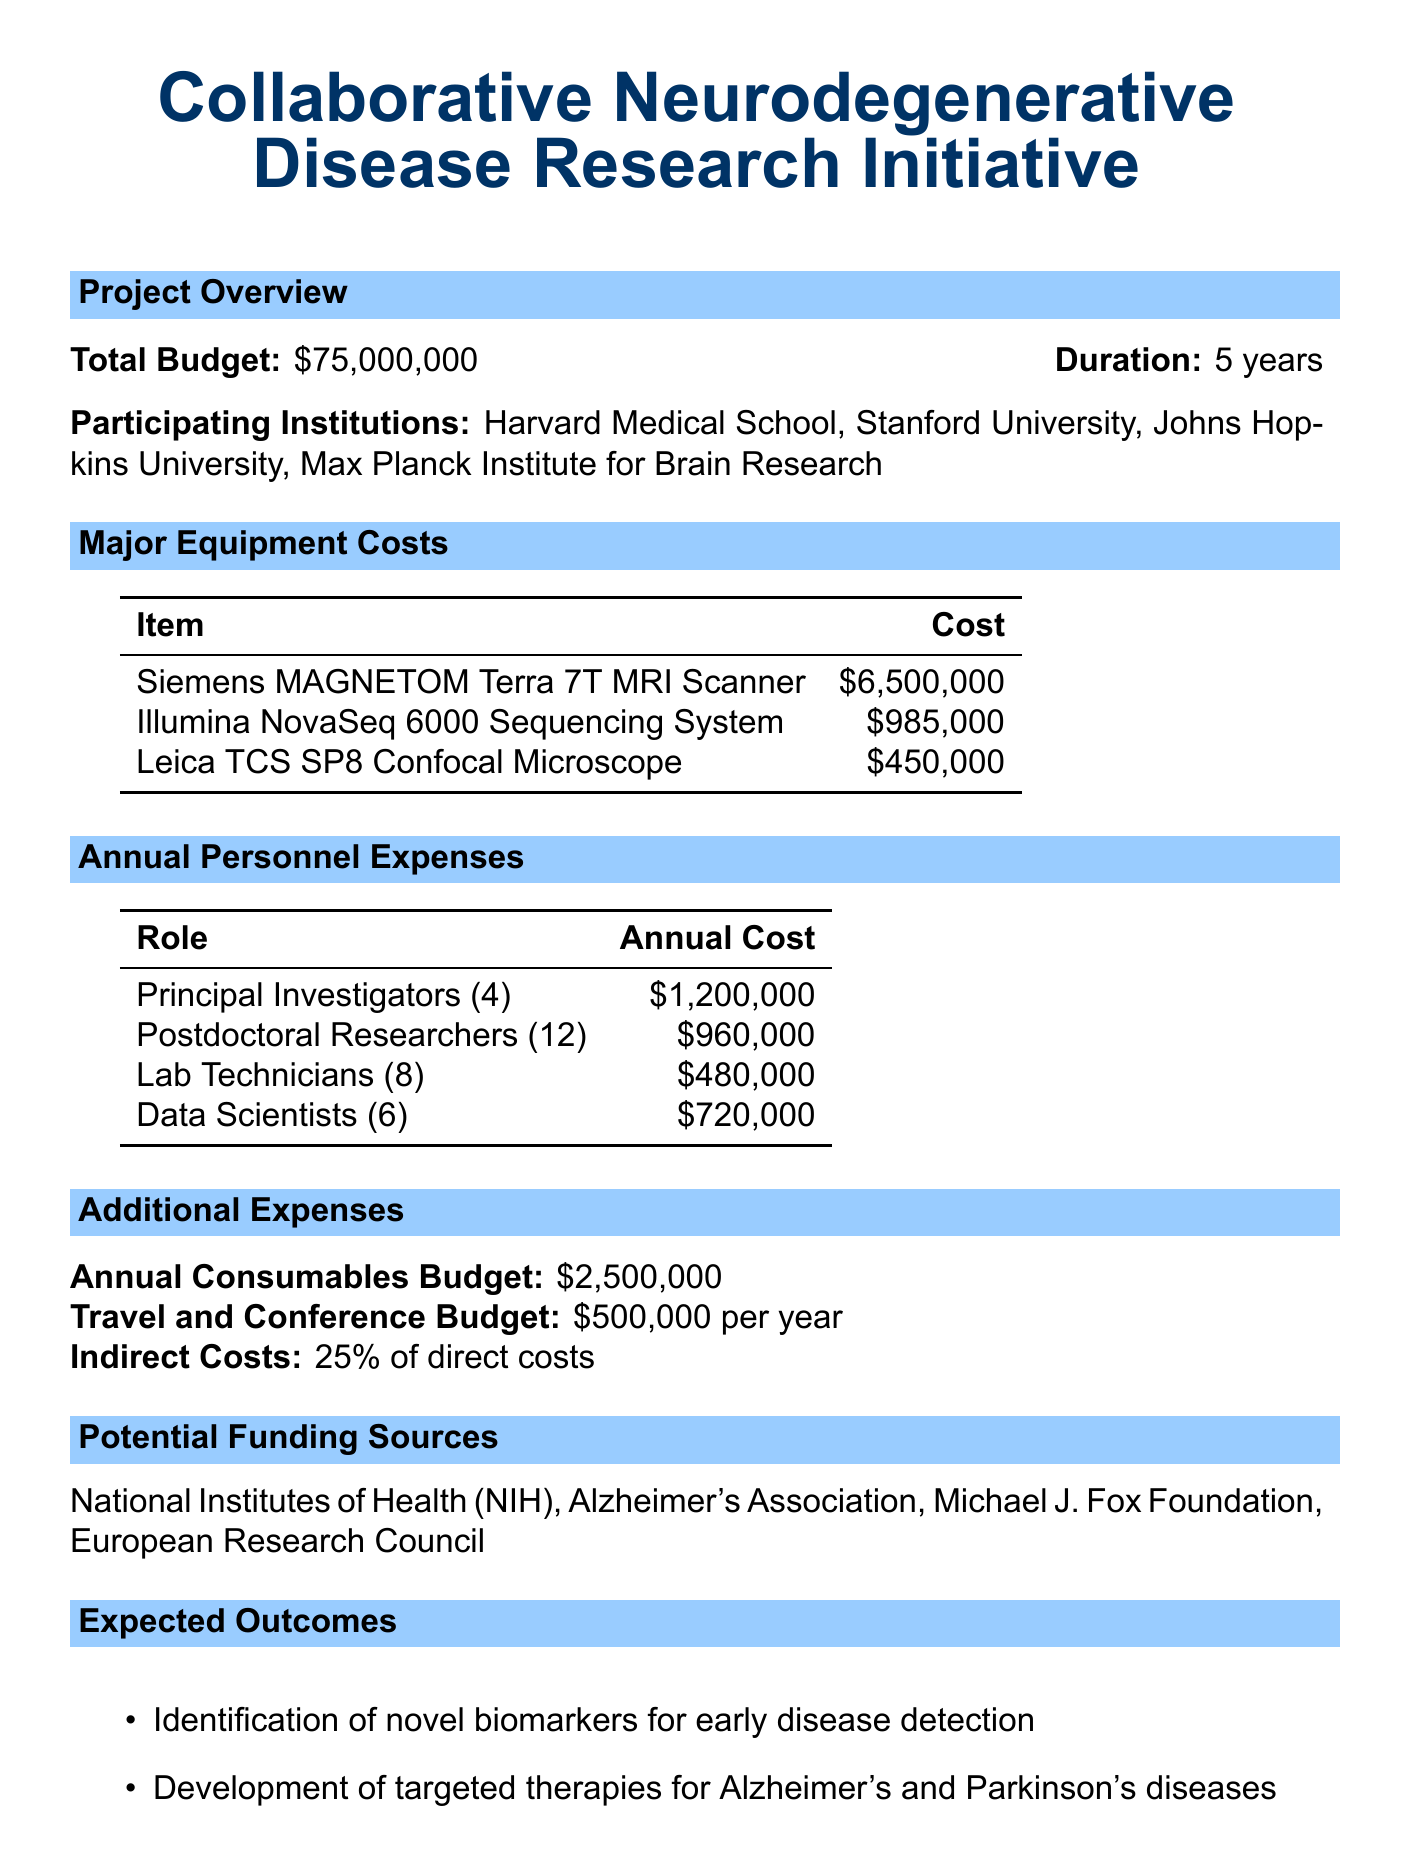What is the total budget for the initiative? The total budget is stated directly in the document as $75,000,000.
Answer: $75,000,000 How many years will the project last? The duration of the project is specified as 5 years.
Answer: 5 years Which institution is involved that is part of the Max Planck Institute? The participating institutions listed include the Max Planck Institute for Brain Research.
Answer: Max Planck Institute for Brain Research What is the cost of the Siemens MAGNETOM Terra 7T MRI Scanner? The cost for this specific equipment is explicitly mentioned as $6,500,000.
Answer: $6,500,000 How many postdoctoral researchers are included in the personnel expenses? The document states there are 12 Postdoctoral Researchers included in the personnel expenses.
Answer: 12 What percentage do indirect costs constitute of direct costs? The indirect costs are stated as 25% of direct costs.
Answer: 25% What is the annual budget allocated for consumables? The annual consumables budget is given as $2,500,000.
Answer: $2,500,000 Name one potential funding source for the project. The document lists several funding sources, including the National Institutes of Health (NIH).
Answer: National Institutes of Health (NIH) What is one expected outcome of the initiative? One expected outcome mentioned is the identification of novel biomarkers for early disease detection.
Answer: Identification of novel biomarkers for early disease detection 